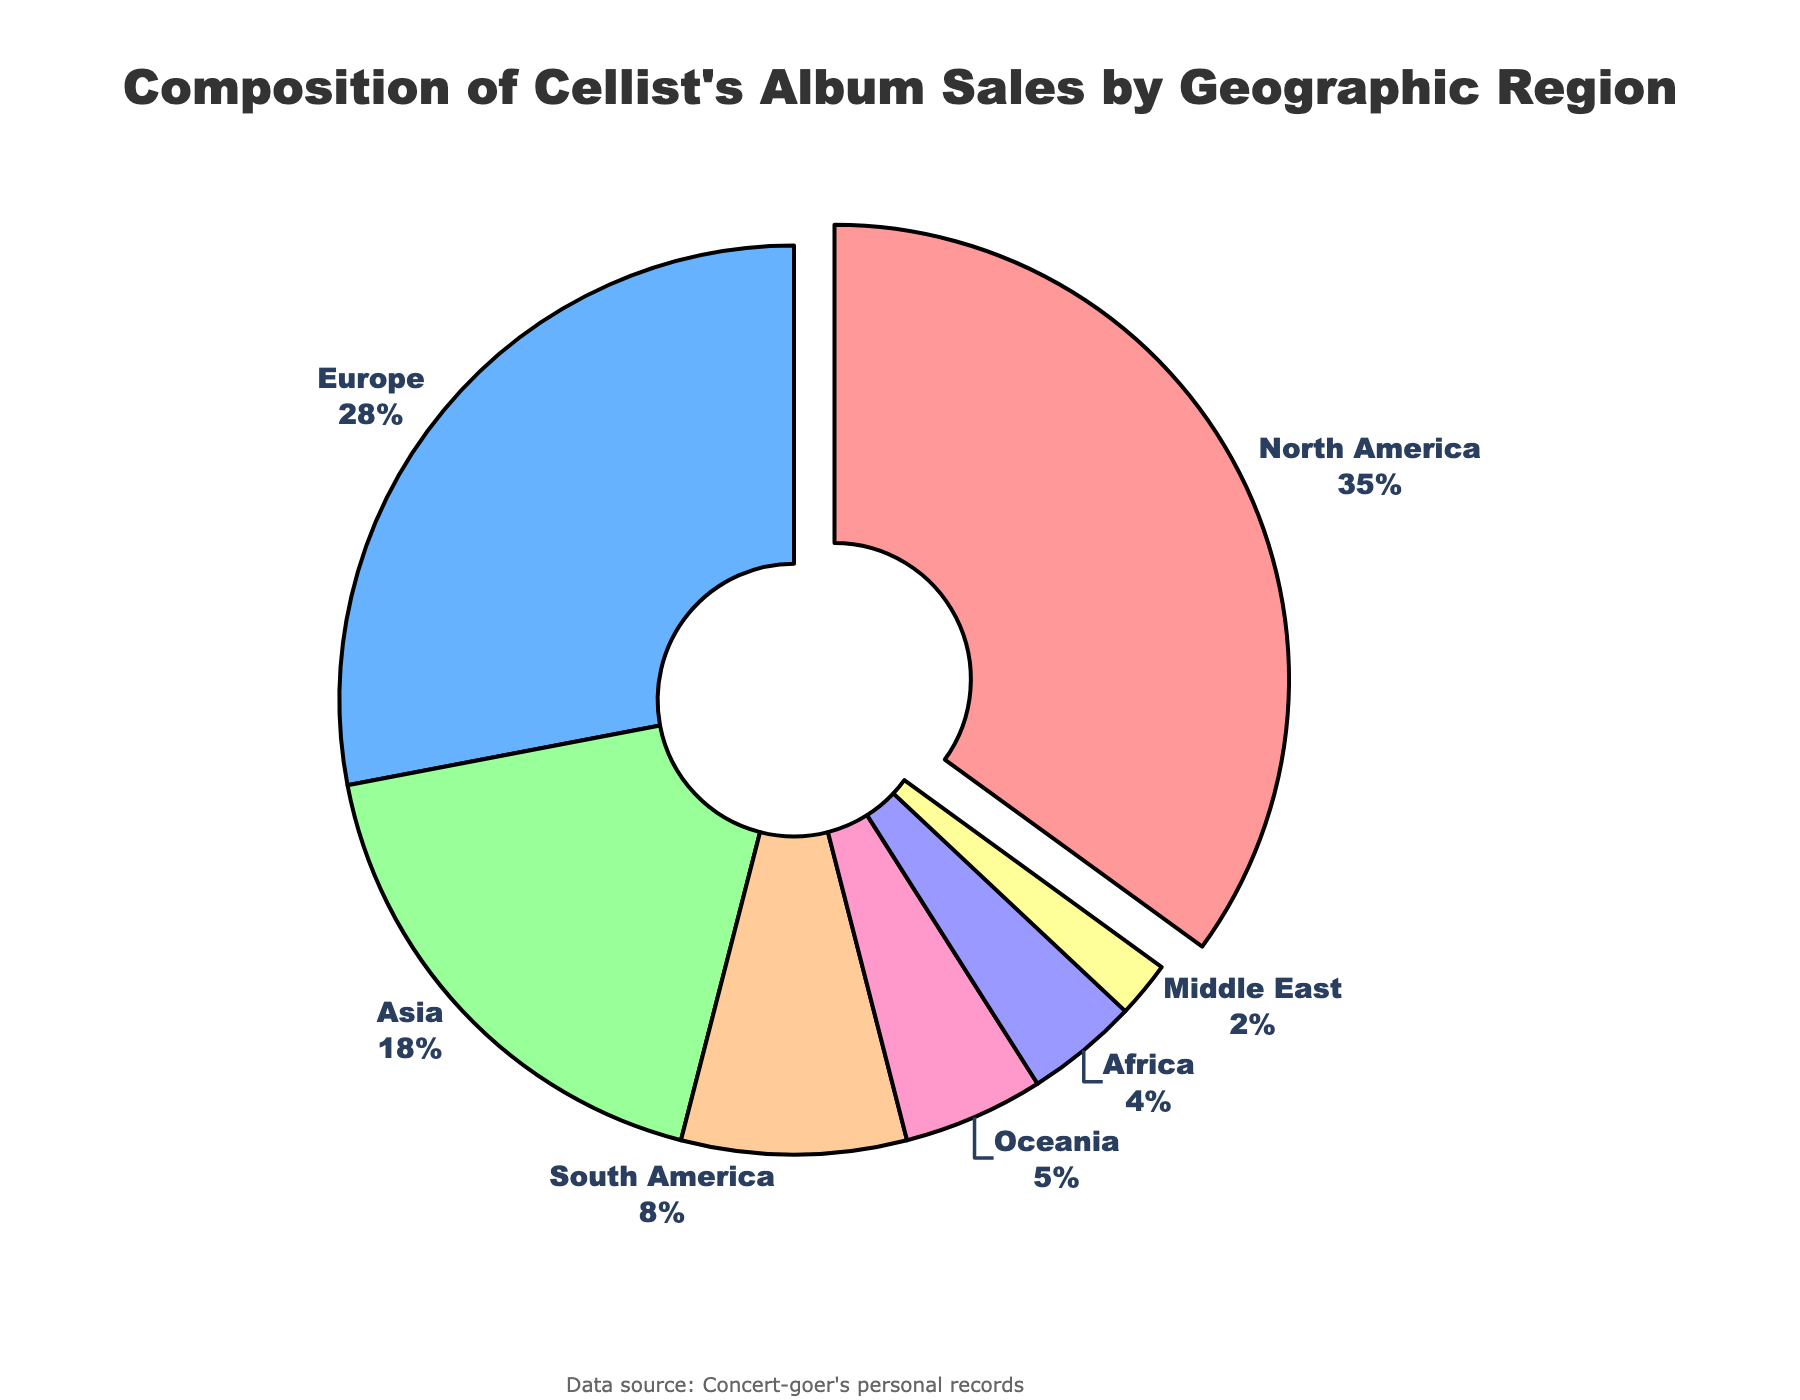What's the region with the highest album sales percentage? North America has the highest album sales percentage, visually evident by the largest pie section and the highest value (35%).
Answer: North America What's the combined album sales percentage of Europe and Asia? Referring to the figure, Europe has 28% and Asia has 18%. Summing these percentages gives 28% + 18% = 46%.
Answer: 46% Which regions have album sales percentages less than 10%? By inspecting the pie chart, South America, Oceania, Africa, and the Middle East have percentages less than 10% (8%, 5%, 4%, and 2%, respectively).
Answer: South America, Oceania, Africa, Middle East What's the difference in album sales percentage between Europe and North America? North America has 35% and Europe has 28%. The difference is 35% - 28% = 7%.
Answer: 7% Which region is represented by the yellow section in the pie chart? The yellow section corresponds to Oceania, which has a 5% album sales percentage. This can be identified by matching the color and the percentage.
Answer: Oceania How much more album sales percentage does North America have compared to Oceania? North America has 35% and Oceania has 5%. The difference is 35% - 5% = 30%.
Answer: 30% Rank the regions by album sales percentage from highest to lowest. From the figure, the order is: North America (35%), Europe (28%), Asia (18%), South America (8%), Oceania (5%), Africa (4%), Middle East (2%).
Answer: North America, Europe, Asia, South America, Oceania, Africa, Middle East What percentage of album sales is from regions other than North America, Europe, and Asia? Summing the percentages of South America, Oceania, Africa, and the Middle East: 8% + 5% + 4% + 2% = 19%.
Answer: 19% 